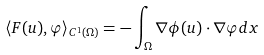Convert formula to latex. <formula><loc_0><loc_0><loc_500><loc_500>\langle F ( u ) , \varphi \rangle _ { C ^ { 1 } ( \Omega ) } = - \int _ { \Omega } \nabla \phi ( u ) \cdot \nabla \varphi d x</formula> 